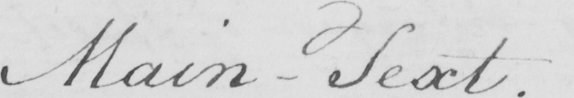Can you tell me what this handwritten text says? Main-Text. 